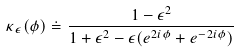Convert formula to latex. <formula><loc_0><loc_0><loc_500><loc_500>\kappa _ { \epsilon } ( \phi ) \doteq \frac { 1 - \epsilon ^ { 2 } } { 1 + \epsilon ^ { 2 } - \epsilon ( e ^ { 2 i \phi } + e ^ { - 2 i \phi } ) }</formula> 